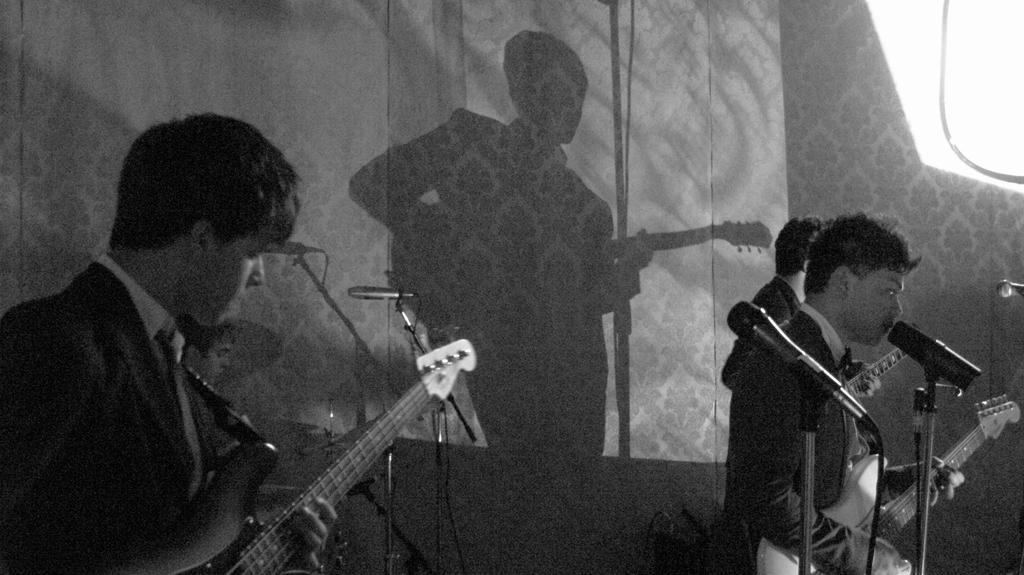How many people are in the image? There are two people in the image. What are the people doing in the image? The people are playing musical instruments. What type of musical instruments are they playing? They are playing guitars. What equipment is present for amplifying or recording their music? There is: There is a microphone and stand in the image. Can you describe any additional elements in the background of the image? There is a reflection of a man at the back side of the image. What type of destruction can be seen in the image? There is no destruction present in the image; it features two people playing guitars, a microphone and stand, and a reflection of a man. What type of voyage are the people embarking on in the image? There is no voyage depicted in the image; it shows people playing musical instruments and related equipment. 